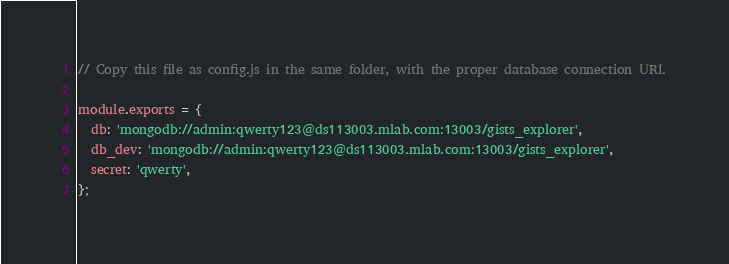Convert code to text. <code><loc_0><loc_0><loc_500><loc_500><_JavaScript_>// Copy this file as config.js in the same folder, with the proper database connection URI.

module.exports = {
  db: 'mongodb://admin:qwerty123@ds113003.mlab.com:13003/gists_explorer',
  db_dev: 'mongodb://admin:qwerty123@ds113003.mlab.com:13003/gists_explorer',
  secret: 'qwerty',
};
</code> 